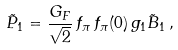<formula> <loc_0><loc_0><loc_500><loc_500>\tilde { P } _ { 1 } = \frac { G _ { F } } { \sqrt { 2 } } \, f _ { \pi } \, f _ { \pi } ( 0 ) \, g _ { 1 } \tilde { B } _ { 1 } \, ,</formula> 